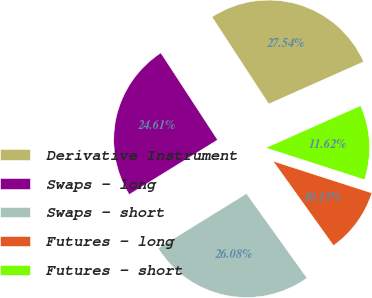Convert chart. <chart><loc_0><loc_0><loc_500><loc_500><pie_chart><fcel>Derivative Instrument<fcel>Swaps - long<fcel>Swaps - short<fcel>Futures - long<fcel>Futures - short<nl><fcel>27.54%<fcel>24.61%<fcel>26.08%<fcel>10.15%<fcel>11.62%<nl></chart> 